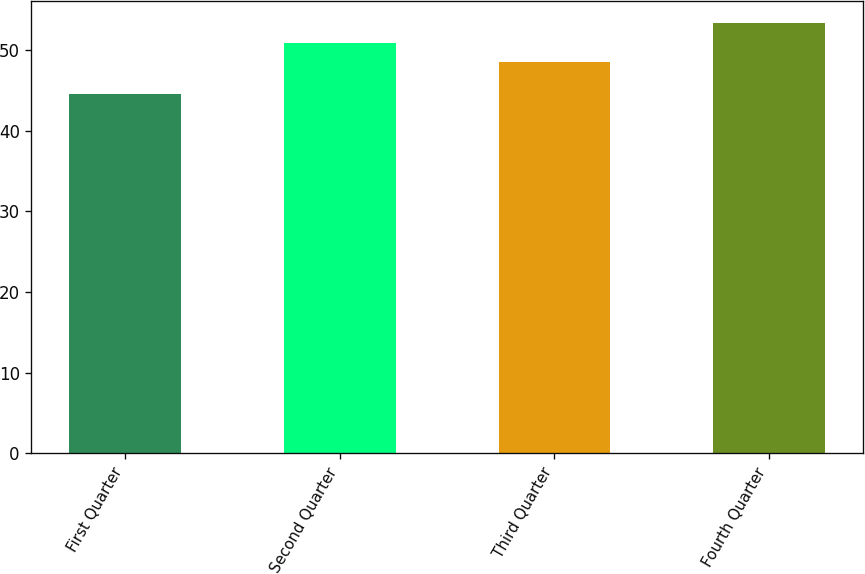Convert chart to OTSL. <chart><loc_0><loc_0><loc_500><loc_500><bar_chart><fcel>First Quarter<fcel>Second Quarter<fcel>Third Quarter<fcel>Fourth Quarter<nl><fcel>44.54<fcel>50.88<fcel>48.56<fcel>53.42<nl></chart> 